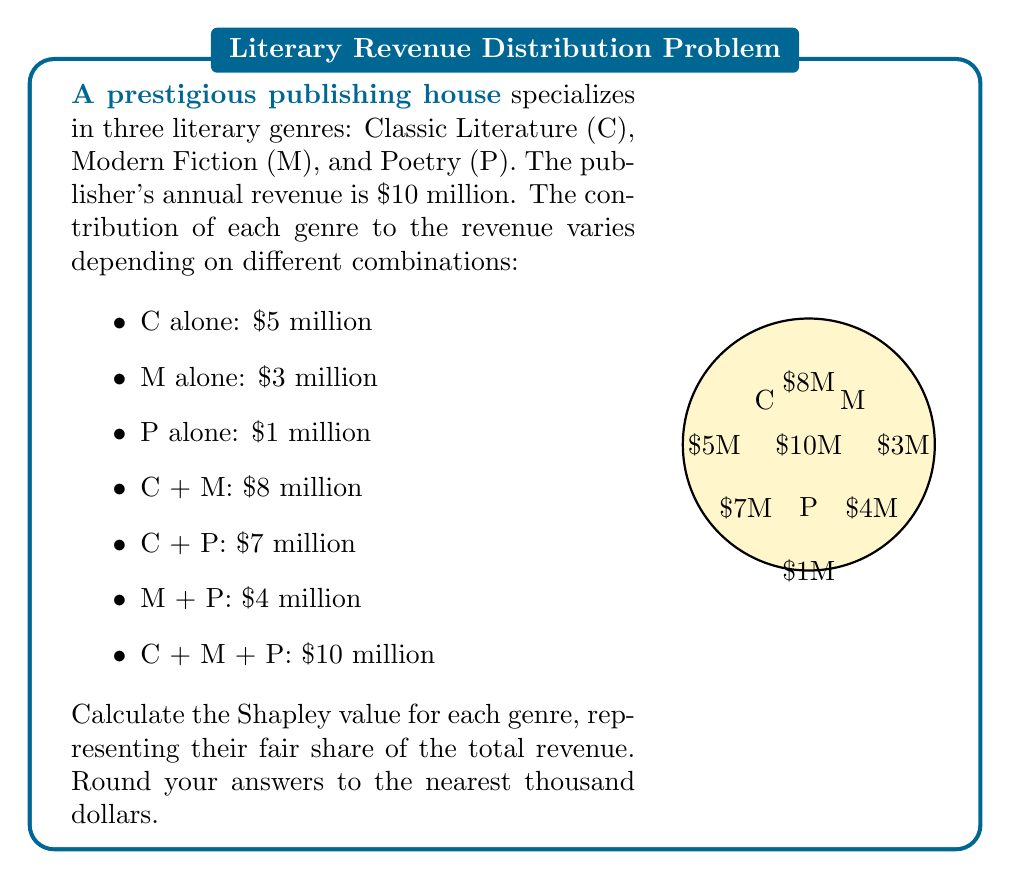Can you solve this math problem? To calculate the Shapley value, we need to consider all possible orderings of the players (genres) and determine their marginal contributions. There are 3! = 6 possible orderings.

Let's calculate the marginal contribution for each genre in each ordering:

1. C, M, P: C = 5, M = 3, P = 2
2. C, P, M: C = 5, P = 2, M = 3
3. M, C, P: M = 3, C = 5, P = 2
4. M, P, C: M = 3, P = 1, C = 6
5. P, C, M: P = 1, C = 6, M = 3
6. P, M, C: P = 1, M = 3, C = 6

Now, let's sum up the marginal contributions for each genre:

Classic Literature (C): 5 + 5 + 5 + 6 + 6 + 6 = 33
Modern Fiction (M): 3 + 3 + 3 + 3 + 3 + 3 = 18
Poetry (P): 2 + 2 + 2 + 1 + 1 + 1 = 9

The Shapley value is the average of these marginal contributions:

Classic Literature: $\frac{33}{6} = 5.5$ million
Modern Fiction: $\frac{18}{6} = 3$ million
Poetry: $\frac{9}{6} = 1.5$ million

Rounding to the nearest thousand:

Classic Literature: $5,500,000
Modern Fiction: $3,000,000
Poetry: $1,500,000

We can verify that the sum of Shapley values equals the total revenue:
$5,500,000 + 3,000,000 + 1,500,000 = 10,000,000$
Answer: C: $5,500,000, M: $3,000,000, P: $1,500,000 